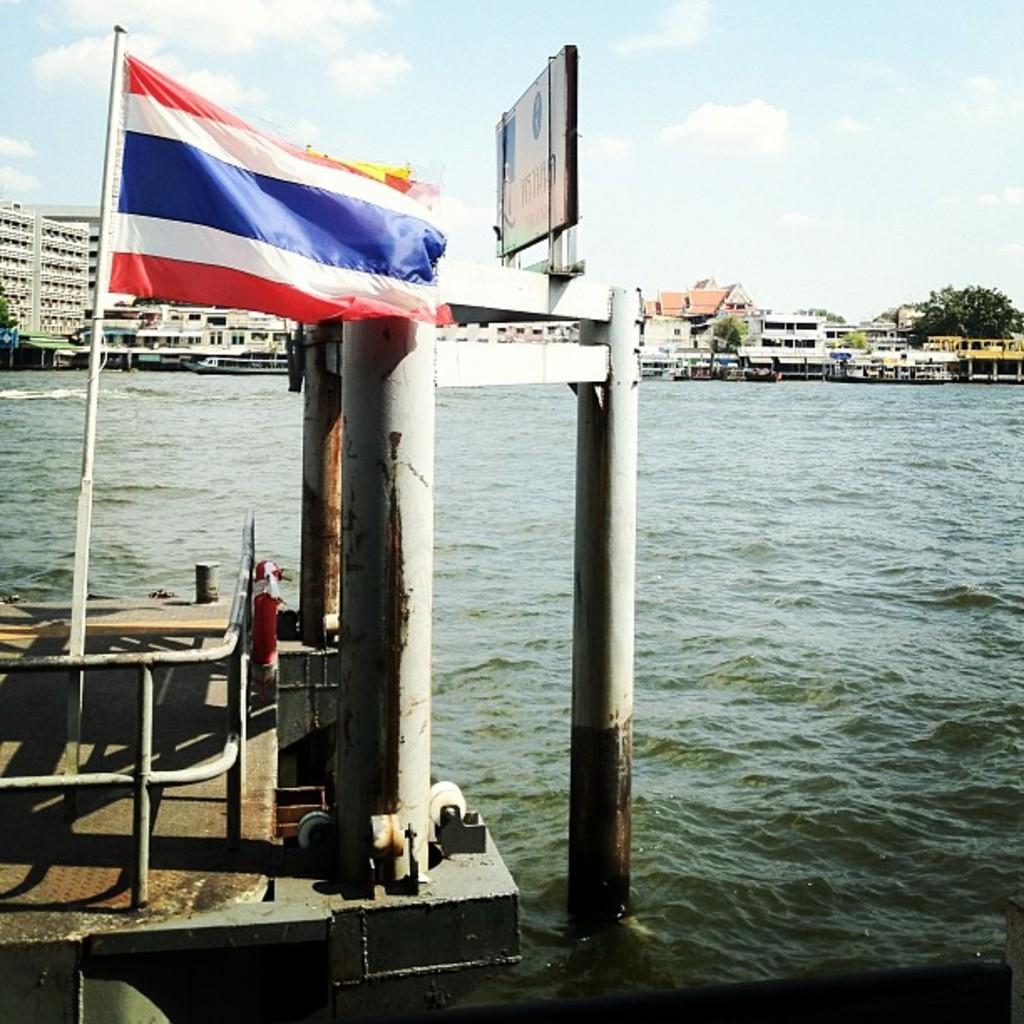Can you describe this image briefly? In the foreground of the image we can see group of poles , metal railing , flag on pole , fire extinguisher. In the background, we can see group of buildings with windows, trees and the sky. 